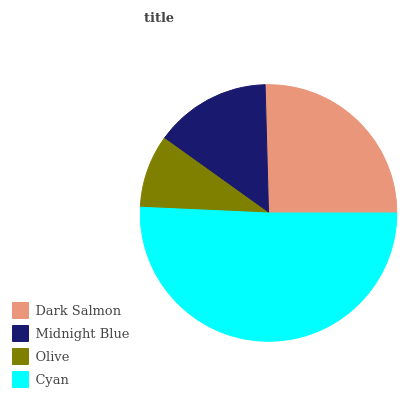Is Olive the minimum?
Answer yes or no. Yes. Is Cyan the maximum?
Answer yes or no. Yes. Is Midnight Blue the minimum?
Answer yes or no. No. Is Midnight Blue the maximum?
Answer yes or no. No. Is Dark Salmon greater than Midnight Blue?
Answer yes or no. Yes. Is Midnight Blue less than Dark Salmon?
Answer yes or no. Yes. Is Midnight Blue greater than Dark Salmon?
Answer yes or no. No. Is Dark Salmon less than Midnight Blue?
Answer yes or no. No. Is Dark Salmon the high median?
Answer yes or no. Yes. Is Midnight Blue the low median?
Answer yes or no. Yes. Is Cyan the high median?
Answer yes or no. No. Is Olive the low median?
Answer yes or no. No. 